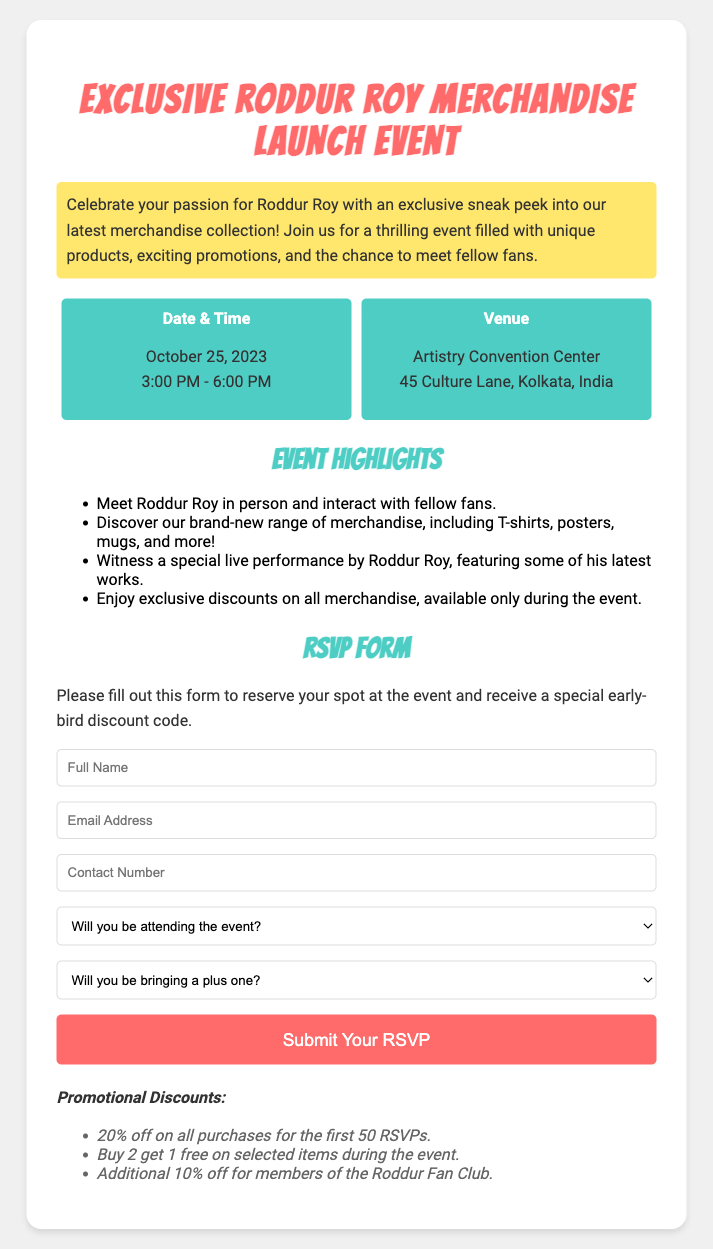What is the date of the event? The event is scheduled for October 25, 2023, as stated in the document.
Answer: October 25, 2023 What time does the event start? The event begins at 3:00 PM, as mentioned in the details section.
Answer: 3:00 PM Where is the venue located? The venue is listed as Artistry Convention Center, which is specified in the document.
Answer: Artistry Convention Center What is the early-bird discount percentage for the first 50 RSVPs? The document states that there is a 20% off promotional discount for the first 50 RSVPs.
Answer: 20% What will attendees be able to enjoy during the event? Attendees can enjoy exclusive discounts, as mentioned in the event highlights.
Answer: Exclusive discounts Will there be a live performance at the event? The document highlights that there will be a special live performance by Roddur Roy, indicating this is a key feature of the event.
Answer: Yes What must you fill out to reserve a spot at the event? The RSVP form needs to be filled out to reserve a spot at the event according to the document's instructions.
Answer: RSVP form What benefits do Roddur Fan Club members receive? It is stated that members of the Roddur Fan Club can receive an additional discount during the event.
Answer: Additional 10% off Is there an option to bring a plus one? The RSVP form provides the option to indicate if a plus one will be brought to the event.
Answer: Yes 